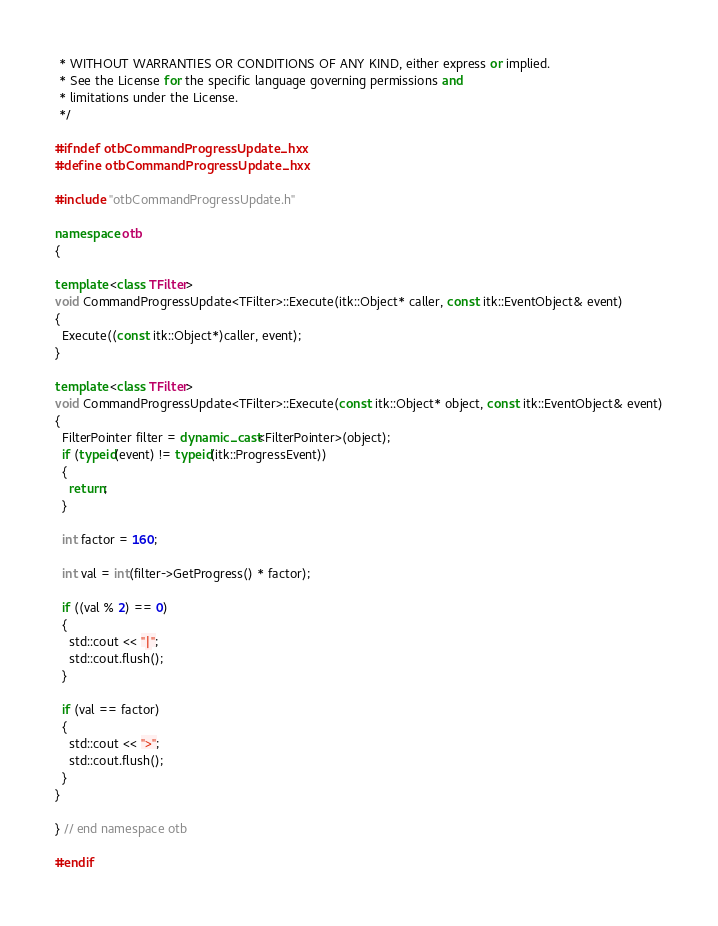<code> <loc_0><loc_0><loc_500><loc_500><_C++_> * WITHOUT WARRANTIES OR CONDITIONS OF ANY KIND, either express or implied.
 * See the License for the specific language governing permissions and
 * limitations under the License.
 */

#ifndef otbCommandProgressUpdate_hxx
#define otbCommandProgressUpdate_hxx

#include "otbCommandProgressUpdate.h"

namespace otb
{

template <class TFilter>
void CommandProgressUpdate<TFilter>::Execute(itk::Object* caller, const itk::EventObject& event)
{
  Execute((const itk::Object*)caller, event);
}

template <class TFilter>
void CommandProgressUpdate<TFilter>::Execute(const itk::Object* object, const itk::EventObject& event)
{
  FilterPointer filter = dynamic_cast<FilterPointer>(object);
  if (typeid(event) != typeid(itk::ProgressEvent))
  {
    return;
  }

  int factor = 160;

  int val = int(filter->GetProgress() * factor);

  if ((val % 2) == 0)
  {
    std::cout << "|";
    std::cout.flush();
  }

  if (val == factor)
  {
    std::cout << ">";
    std::cout.flush();
  }
}

} // end namespace otb

#endif
</code> 